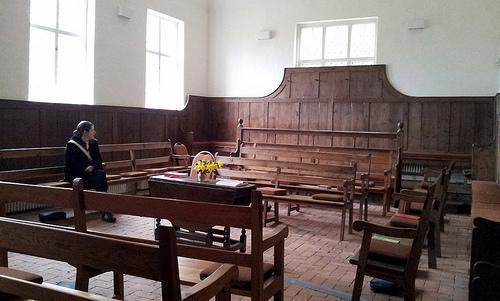How many people are in the room?
Give a very brief answer. 1. 